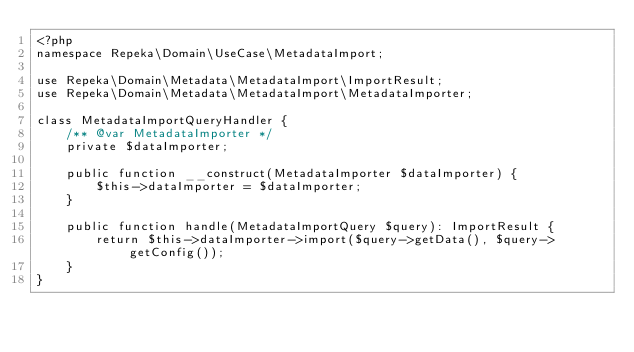<code> <loc_0><loc_0><loc_500><loc_500><_PHP_><?php
namespace Repeka\Domain\UseCase\MetadataImport;

use Repeka\Domain\Metadata\MetadataImport\ImportResult;
use Repeka\Domain\Metadata\MetadataImport\MetadataImporter;

class MetadataImportQueryHandler {
    /** @var MetadataImporter */
    private $dataImporter;

    public function __construct(MetadataImporter $dataImporter) {
        $this->dataImporter = $dataImporter;
    }

    public function handle(MetadataImportQuery $query): ImportResult {
        return $this->dataImporter->import($query->getData(), $query->getConfig());
    }
}
</code> 